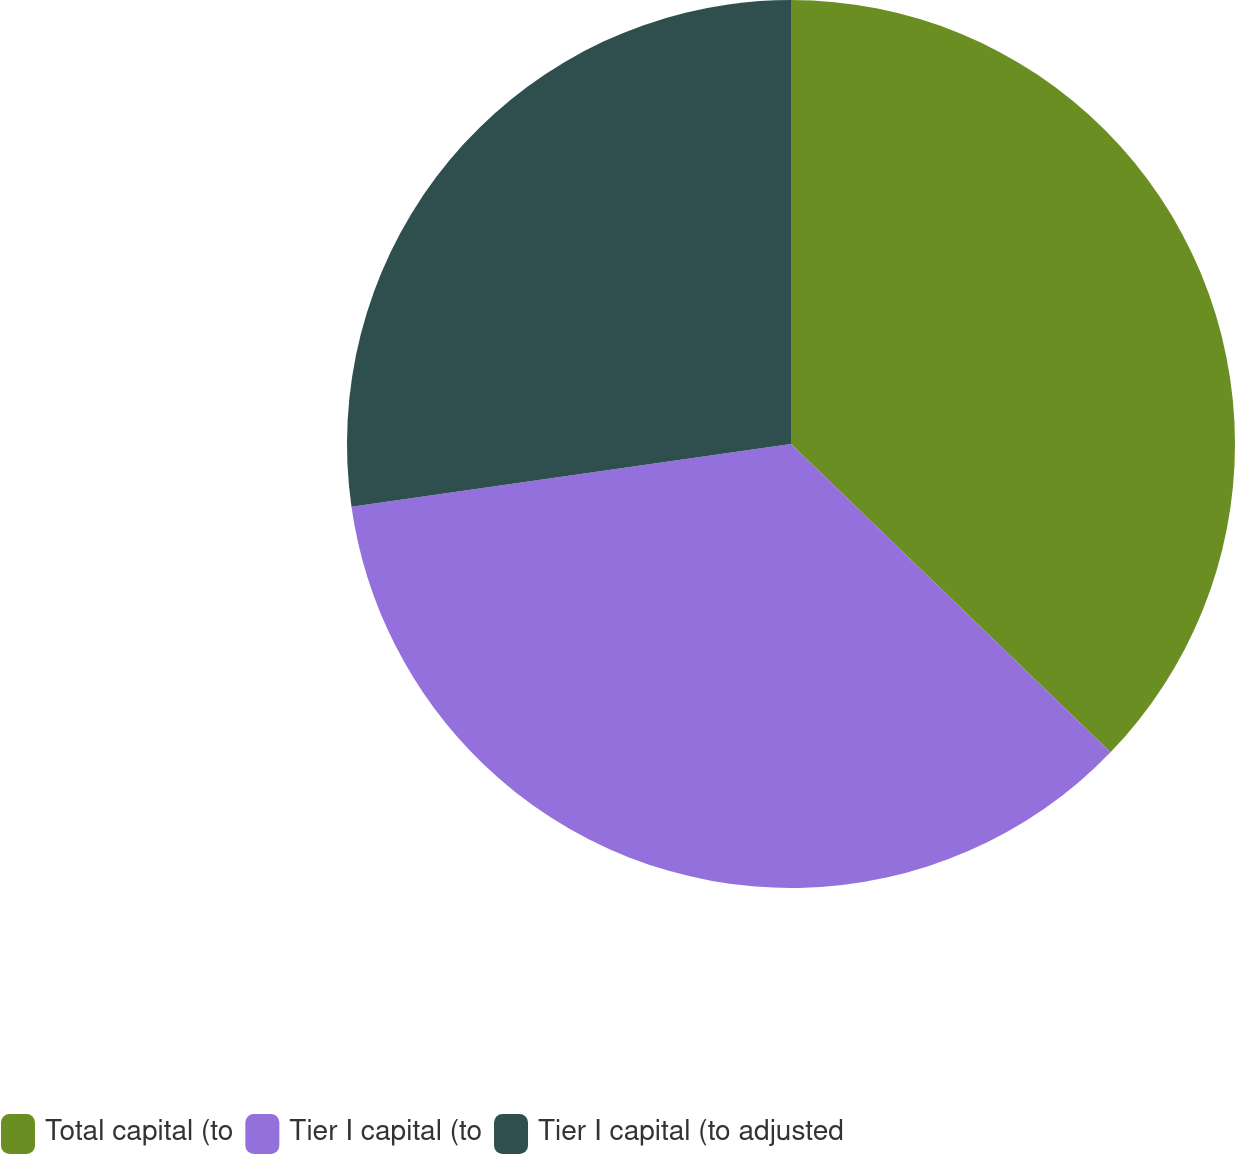Convert chart to OTSL. <chart><loc_0><loc_0><loc_500><loc_500><pie_chart><fcel>Total capital (to<fcel>Tier I capital (to<fcel>Tier I capital (to adjusted<nl><fcel>37.22%<fcel>35.53%<fcel>27.26%<nl></chart> 